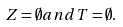Convert formula to latex. <formula><loc_0><loc_0><loc_500><loc_500>Z = \emptyset a n d T = \emptyset .</formula> 